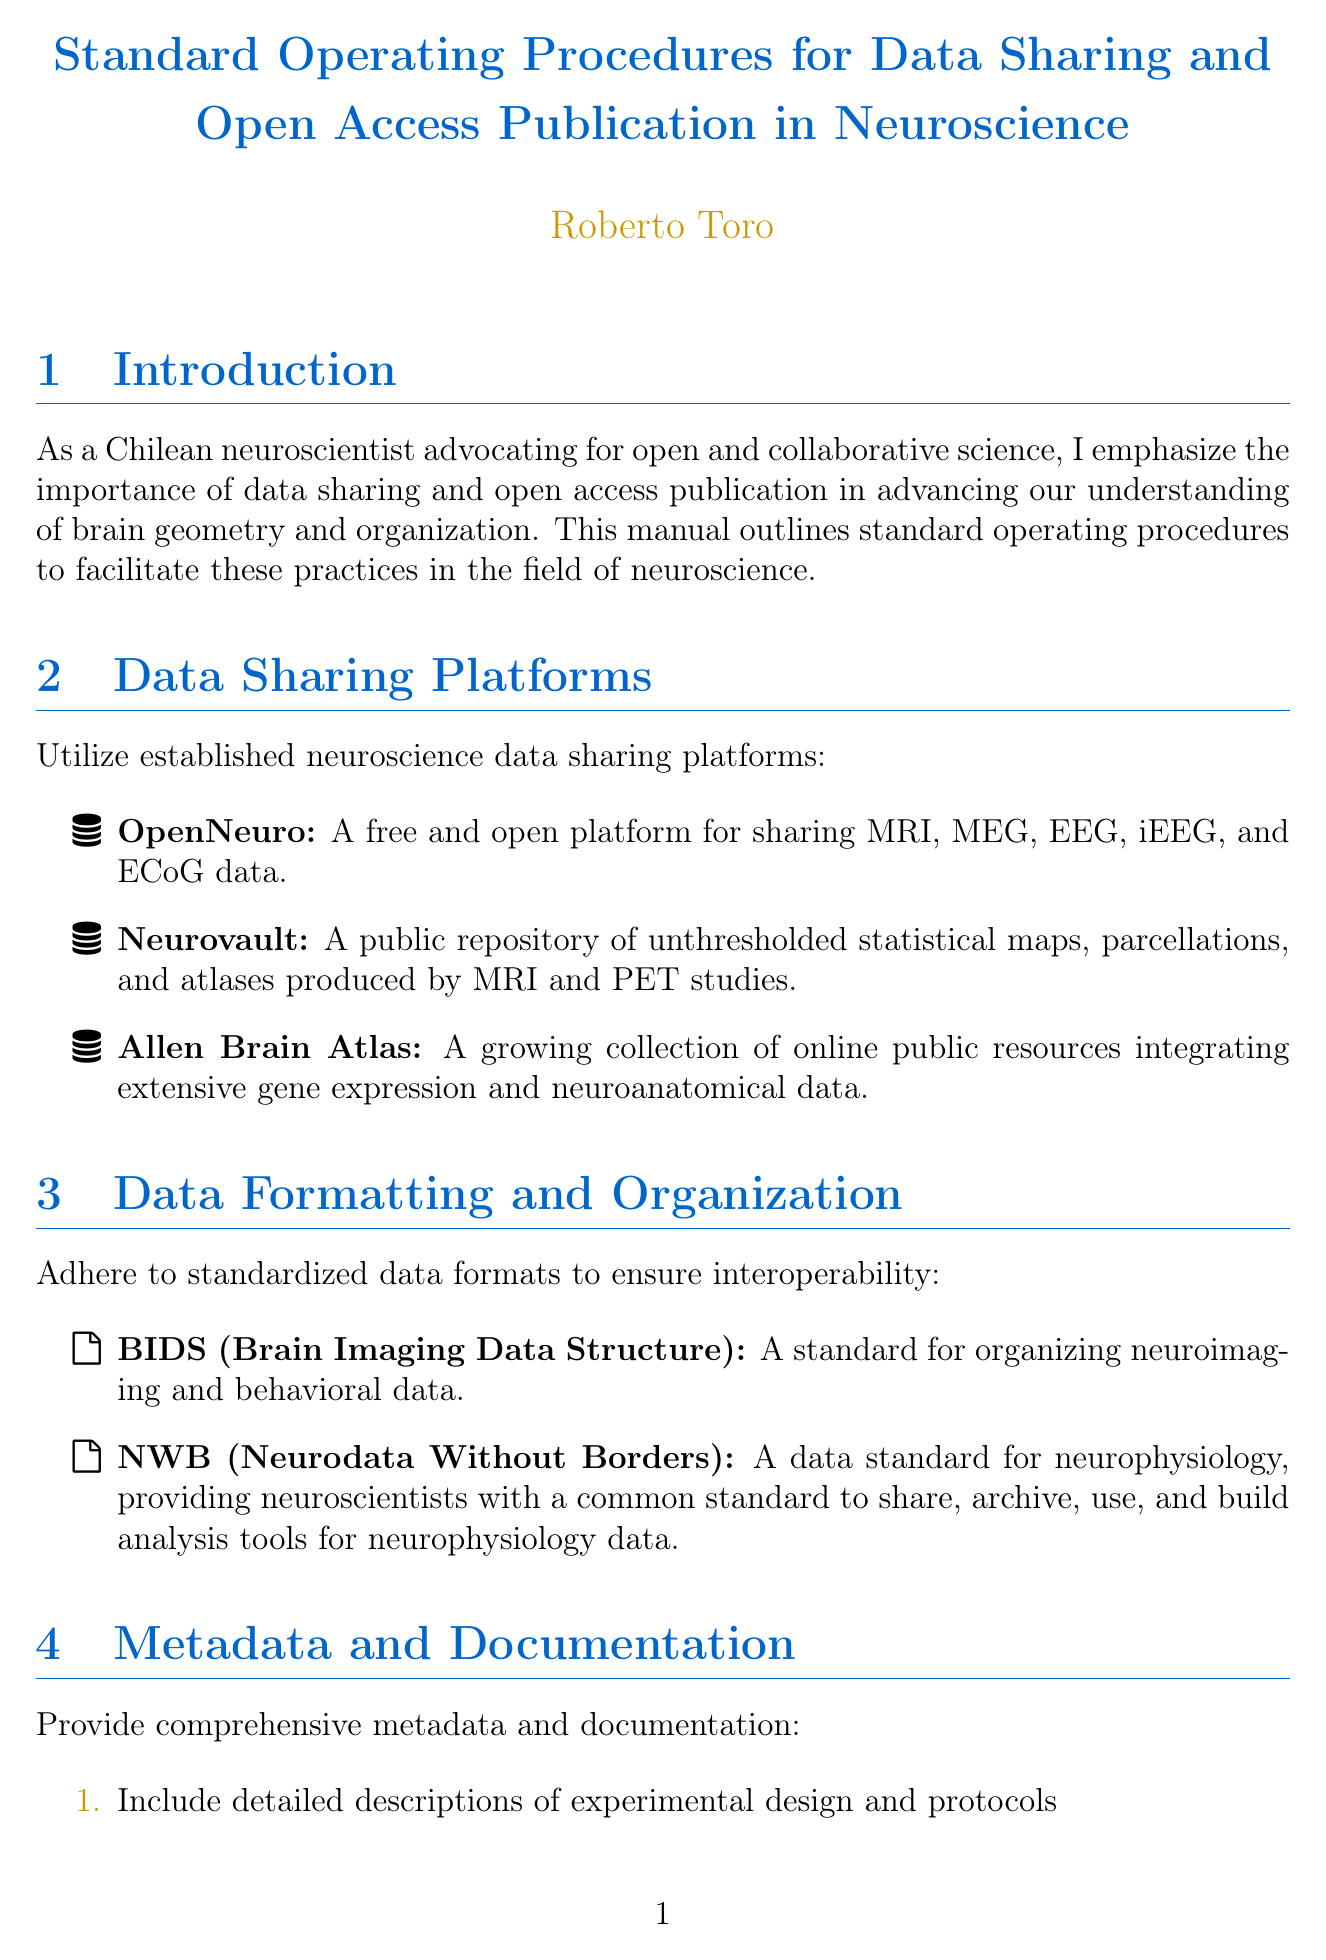What is the title of the manual? The title of the manual is stated at the beginning of the document.
Answer: Standard Operating Procedures for Data Sharing and Open Access Publication in Neuroscience Who is the author of the manual? The author information is provided next to the title.
Answer: Roberto Toro Name one data sharing platform mentioned in the document. The section on data sharing platforms lists several, of which one can be selected.
Answer: OpenNeuro What standard is mentioned for organizing neuroimaging data? A section specifically dedicates to data formatting for organization includes this standard.
Answer: BIDS What is a recommended journal for open access publication? The document lists open access journals, and one can be named from the list.
Answer: eLife How many steps are included in the metadata and documentation section? The document provides a numbered list of steps in that section.
Answer: Four What is one ethical consideration addressed in the manual? The ethical considerations section lists several points, any of which can be chosen.
Answer: Informed consent What type of tool is GitHub classified as in this document? The collaborative tools section categorizes different tools, including this one.
Answer: Collaborative tool 